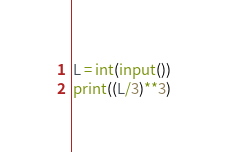<code> <loc_0><loc_0><loc_500><loc_500><_Python_>L = int(input())
print((L/3)**3)</code> 